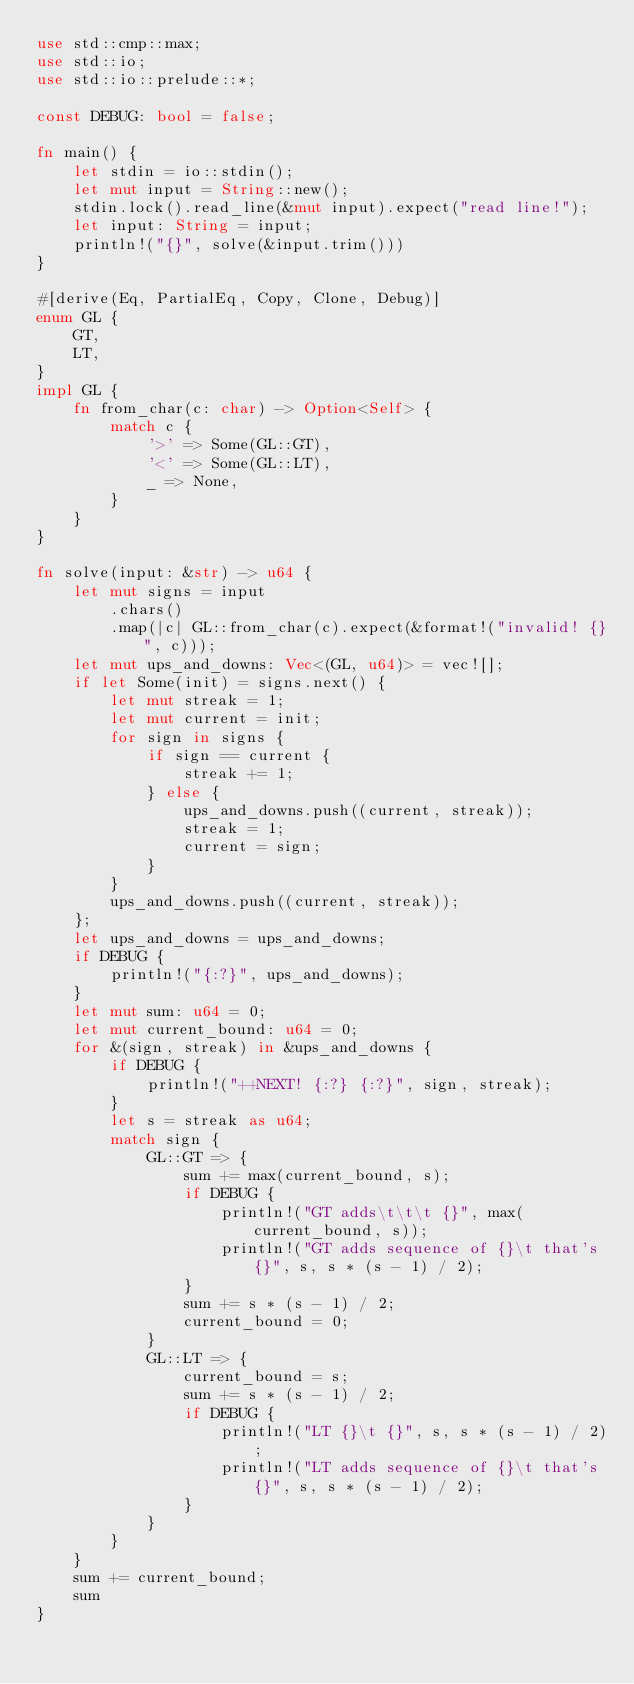Convert code to text. <code><loc_0><loc_0><loc_500><loc_500><_Rust_>use std::cmp::max;
use std::io;
use std::io::prelude::*;

const DEBUG: bool = false;

fn main() {
    let stdin = io::stdin();
    let mut input = String::new();
    stdin.lock().read_line(&mut input).expect("read line!");
    let input: String = input;
    println!("{}", solve(&input.trim()))
}

#[derive(Eq, PartialEq, Copy, Clone, Debug)]
enum GL {
    GT,
    LT,
}
impl GL {
    fn from_char(c: char) -> Option<Self> {
        match c {
            '>' => Some(GL::GT),
            '<' => Some(GL::LT),
            _ => None,
        }
    }
}

fn solve(input: &str) -> u64 {
    let mut signs = input
        .chars()
        .map(|c| GL::from_char(c).expect(&format!("invalid! {}", c)));
    let mut ups_and_downs: Vec<(GL, u64)> = vec![];
    if let Some(init) = signs.next() {
        let mut streak = 1;
        let mut current = init;
        for sign in signs {
            if sign == current {
                streak += 1;
            } else {
                ups_and_downs.push((current, streak));
                streak = 1;
                current = sign;
            }
        }
        ups_and_downs.push((current, streak));
    };
    let ups_and_downs = ups_and_downs;
    if DEBUG {
        println!("{:?}", ups_and_downs);
    }
    let mut sum: u64 = 0;
    let mut current_bound: u64 = 0;
    for &(sign, streak) in &ups_and_downs {
        if DEBUG {
            println!("++NEXT! {:?} {:?}", sign, streak);
        }
        let s = streak as u64;
        match sign {
            GL::GT => {
                sum += max(current_bound, s);
                if DEBUG {
                    println!("GT adds\t\t\t {}", max(current_bound, s));
                    println!("GT adds sequence of {}\t that's {}", s, s * (s - 1) / 2);
                }
                sum += s * (s - 1) / 2;
                current_bound = 0;
            }
            GL::LT => {
                current_bound = s;
                sum += s * (s - 1) / 2;
                if DEBUG {
                    println!("LT {}\t {}", s, s * (s - 1) / 2);
                    println!("LT adds sequence of {}\t that's {}", s, s * (s - 1) / 2);
                }
            }
        }
    }
    sum += current_bound;
    sum
}
</code> 